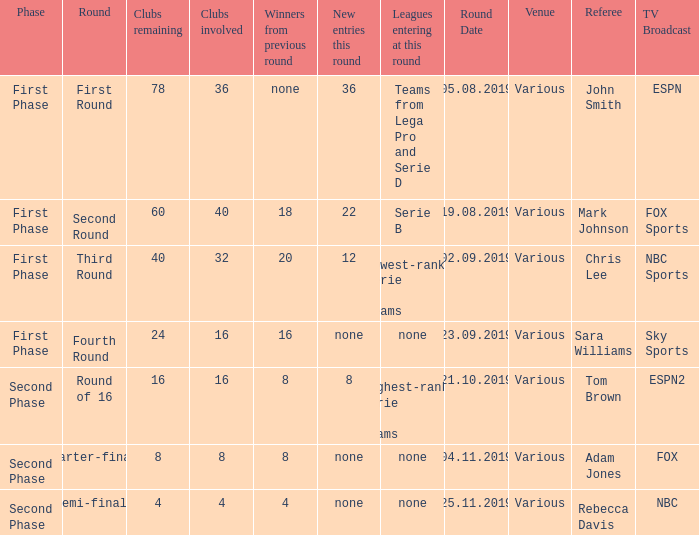During the first phase portion of phase and having 16 clubs involved; what would you find for the winners from previous round? 16.0. 